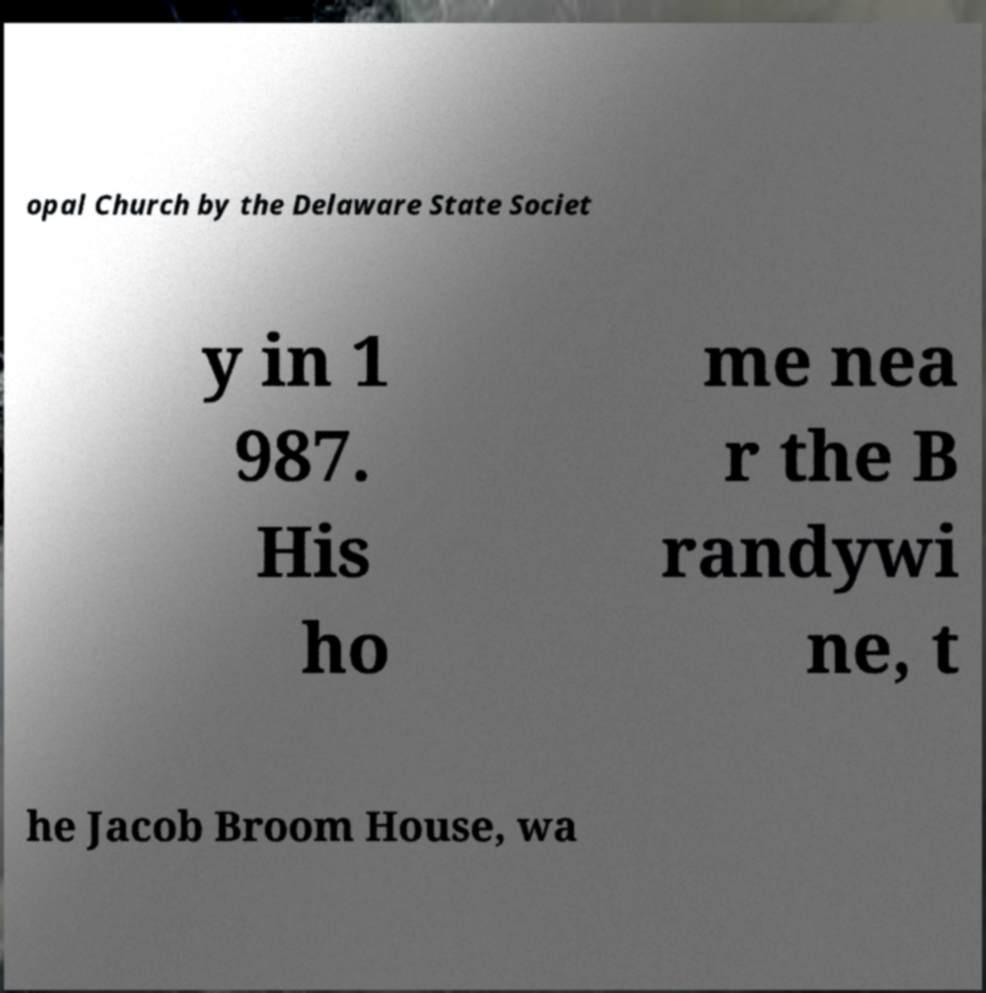Can you read and provide the text displayed in the image?This photo seems to have some interesting text. Can you extract and type it out for me? opal Church by the Delaware State Societ y in 1 987. His ho me nea r the B randywi ne, t he Jacob Broom House, wa 